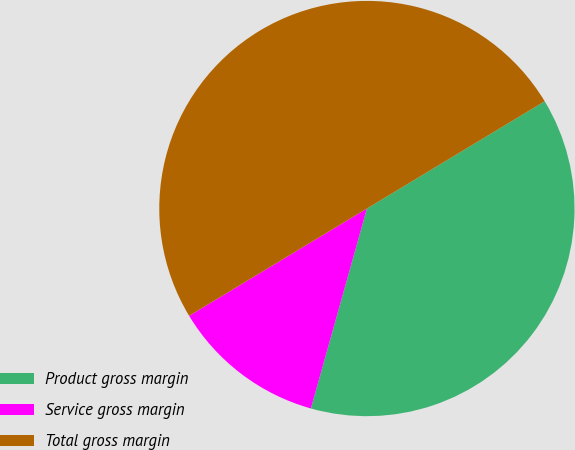Convert chart. <chart><loc_0><loc_0><loc_500><loc_500><pie_chart><fcel>Product gross margin<fcel>Service gross margin<fcel>Total gross margin<nl><fcel>37.99%<fcel>12.01%<fcel>50.0%<nl></chart> 